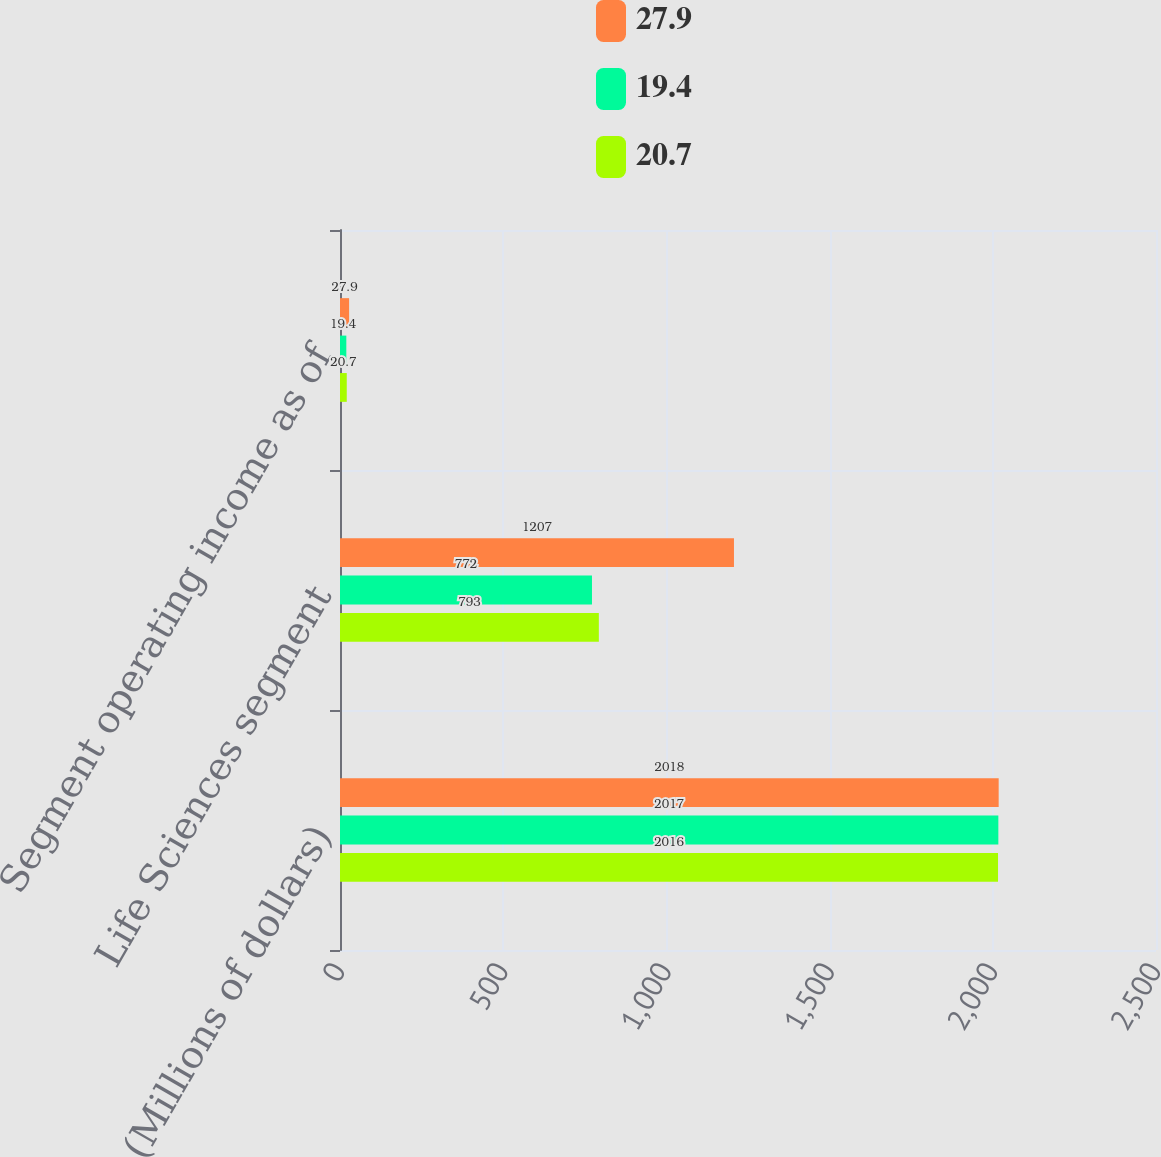<chart> <loc_0><loc_0><loc_500><loc_500><stacked_bar_chart><ecel><fcel>(Millions of dollars)<fcel>Life Sciences segment<fcel>Segment operating income as of<nl><fcel>27.9<fcel>2018<fcel>1207<fcel>27.9<nl><fcel>19.4<fcel>2017<fcel>772<fcel>19.4<nl><fcel>20.7<fcel>2016<fcel>793<fcel>20.7<nl></chart> 